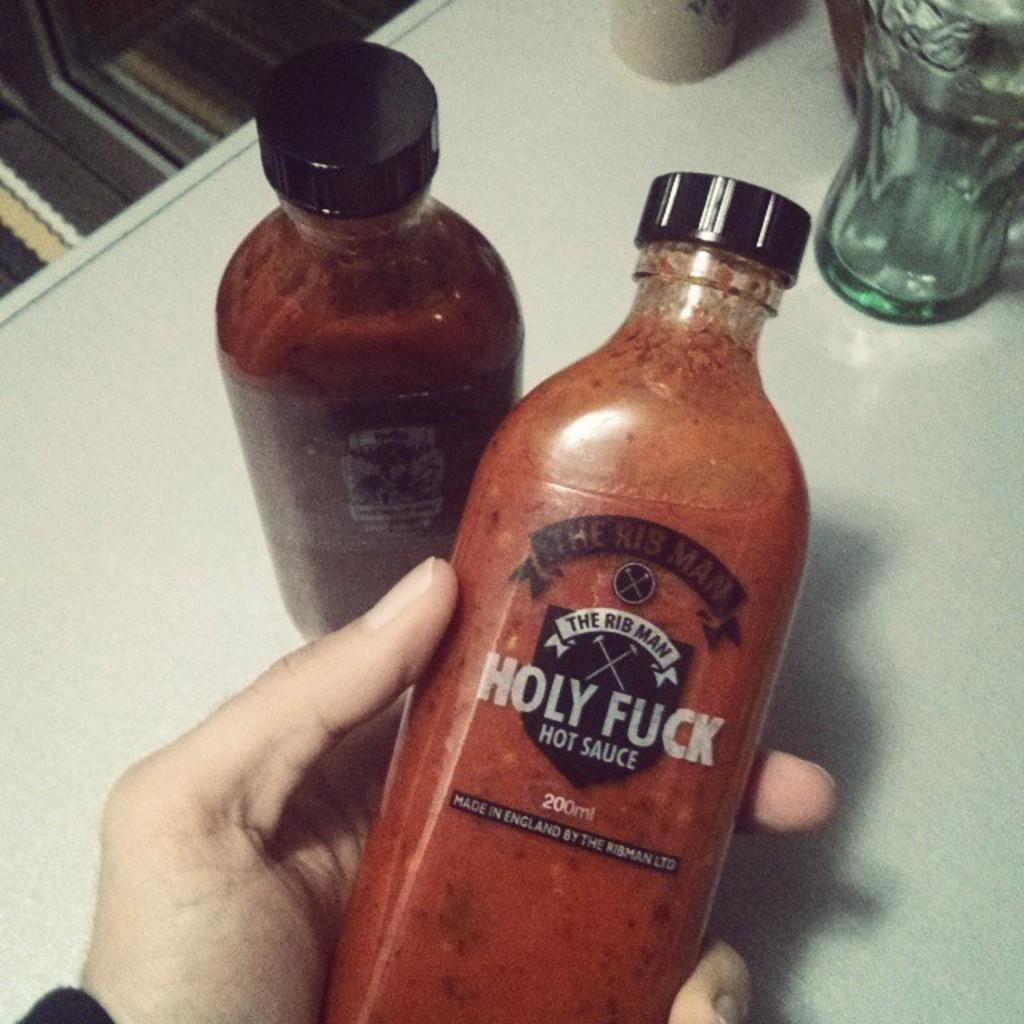<image>
Render a clear and concise summary of the photo. some one is holding a bottle of holy fuck 